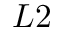Convert formula to latex. <formula><loc_0><loc_0><loc_500><loc_500>L 2</formula> 